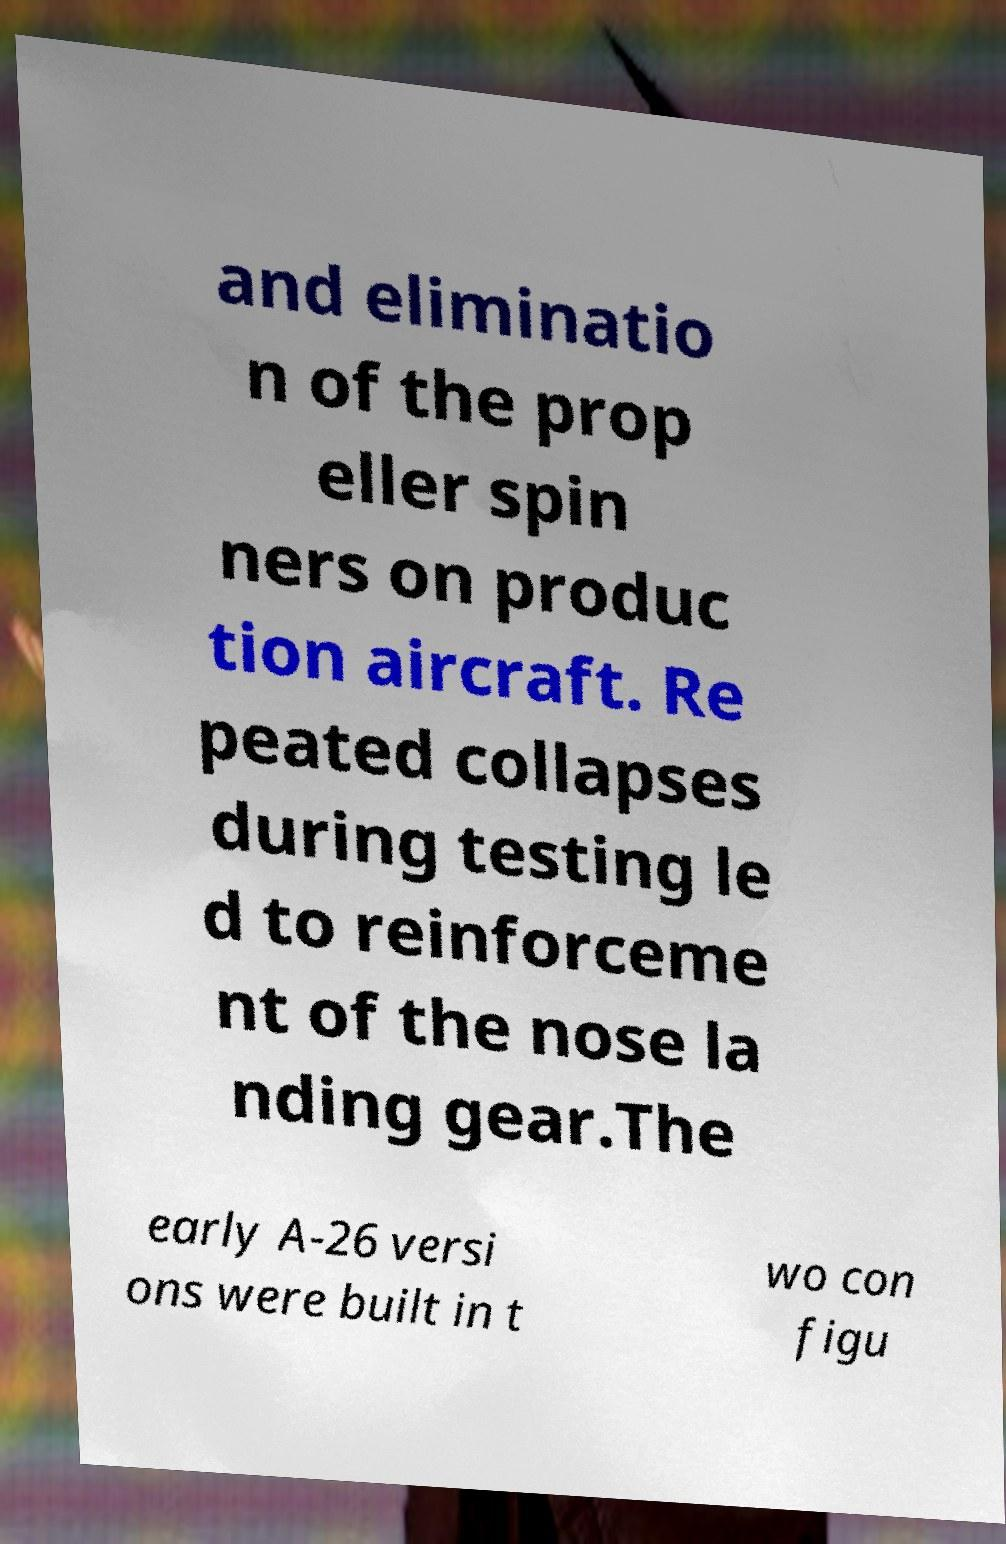What messages or text are displayed in this image? I need them in a readable, typed format. and eliminatio n of the prop eller spin ners on produc tion aircraft. Re peated collapses during testing le d to reinforceme nt of the nose la nding gear.The early A-26 versi ons were built in t wo con figu 